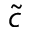<formula> <loc_0><loc_0><loc_500><loc_500>\tilde { c }</formula> 